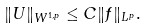<formula> <loc_0><loc_0><loc_500><loc_500>\| U \| _ { W ^ { 1 , p } } \leq C \| f \| _ { L ^ { p } } .</formula> 